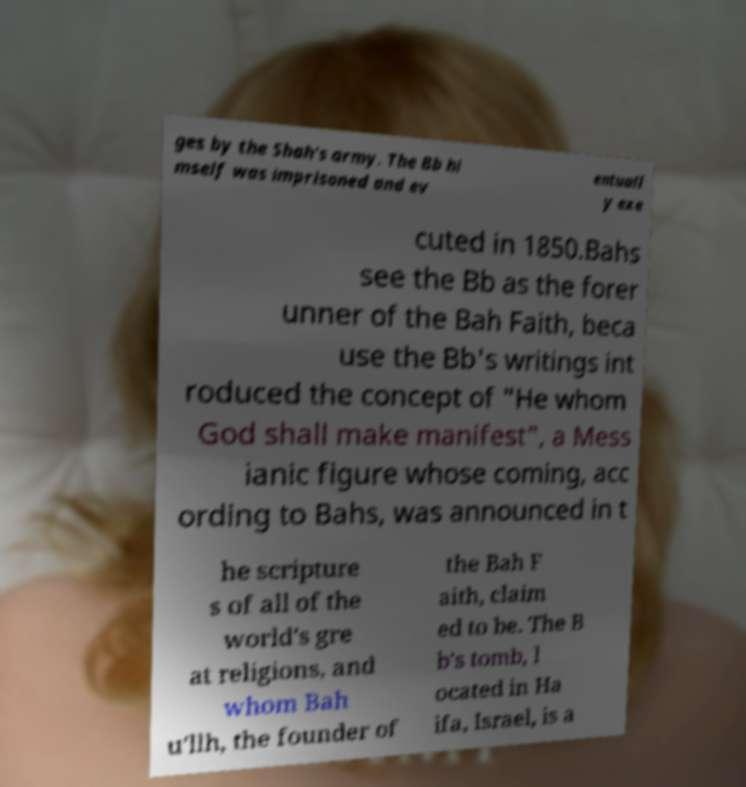Please identify and transcribe the text found in this image. ges by the Shah's army. The Bb hi mself was imprisoned and ev entuall y exe cuted in 1850.Bahs see the Bb as the forer unner of the Bah Faith, beca use the Bb's writings int roduced the concept of "He whom God shall make manifest", a Mess ianic figure whose coming, acc ording to Bahs, was announced in t he scripture s of all of the world's gre at religions, and whom Bah u'llh, the founder of the Bah F aith, claim ed to be. The B b's tomb, l ocated in Ha ifa, Israel, is a 